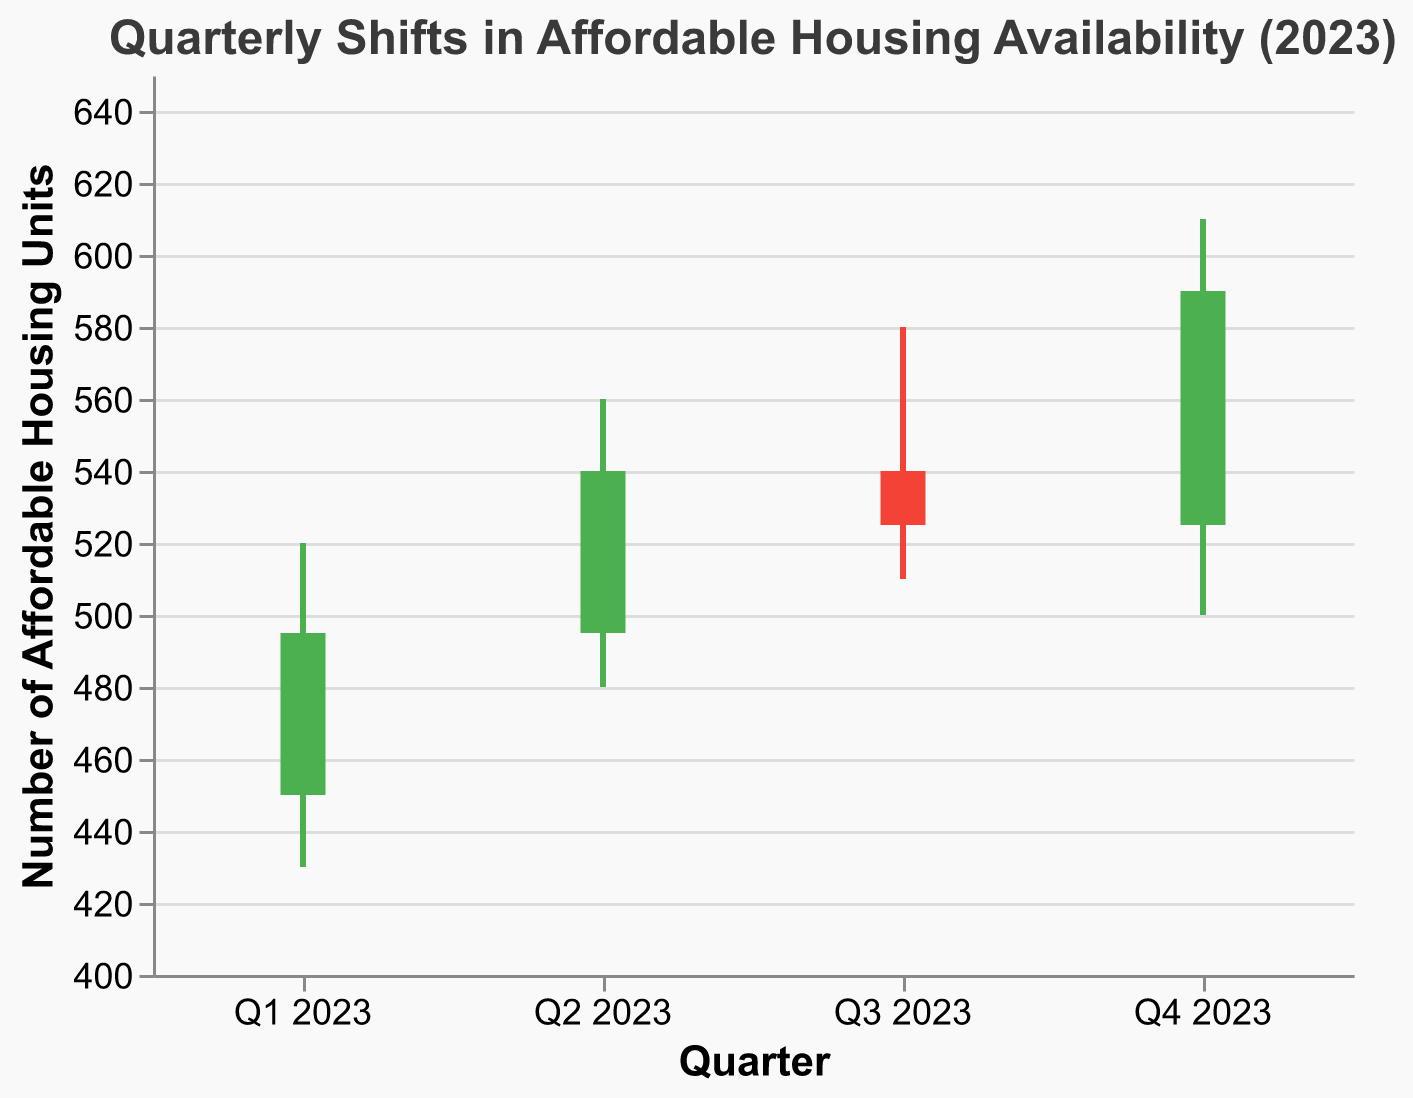What is the title of the chart? The title of the chart is located at the top and reads "Quarterly Shifts in Affordable Housing Availability (2023)."
Answer: Quarterly Shifts in Affordable Housing Availability (2023) How many quarters are displayed in the chart? The X-axis labels show four different quarters—Q1 2023, Q2 2023, Q3 2023, and Q4 2023.
Answer: 4 What was the highest number of affordable housing units in Q4 2023? The high value for Q4 2023 is indicated by the top of the vertical line and shows 610 units.
Answer: 610 In which quarter did the availability of affordable housing units decrease from the opening to the closing? This can be identified by the color of the bar. In Q3 2023, the bar is red, showing the Close (525) is less than the Open (540).
Answer: Q3 2023 What is the range of affordable housing units in Q2 2023? The range is calculated by subtracting the Low value from the High value. For Q2 2023, it is 560 - 480 = 80 units.
Answer: 80 units Which quarter had the smallest difference between its opening and closing values? Calculate the differences for each quarter: Q1 (495-450=45), Q2 (540-495=45), Q3 (525-540=-15), Q4 (590-525=65). The smallest (absolute) difference is 15, for Q3 2023.
Answer: Q3 2023 What was the closing value of affordable housing units in Q1 2023? Referring to the bar's closing value for Q1 2023, it is indicated as 495 units.
Answer: 495 Compare the High values of Q3 2023 and Q4 2023. Which quarter had a higher peak? Q4 2023 had a High value of 610, which is higher than Q3 2023 with a High value of 580.
Answer: Q4 2023 What is the trend in the closing values from Q1 to Q4 2023? By observing the closing value for each quarter (Q1: 495, Q2: 540, Q3: 525, Q4: 590), we see a general upward trend with a slight dip in Q3.
Answer: Upward trend Between Q1 and Q2 of 2023, by how much did the Low value increase? Subtract the Low value of Q1 from the Low value of Q2 (480 - 430 = 50).
Answer: 50 units 